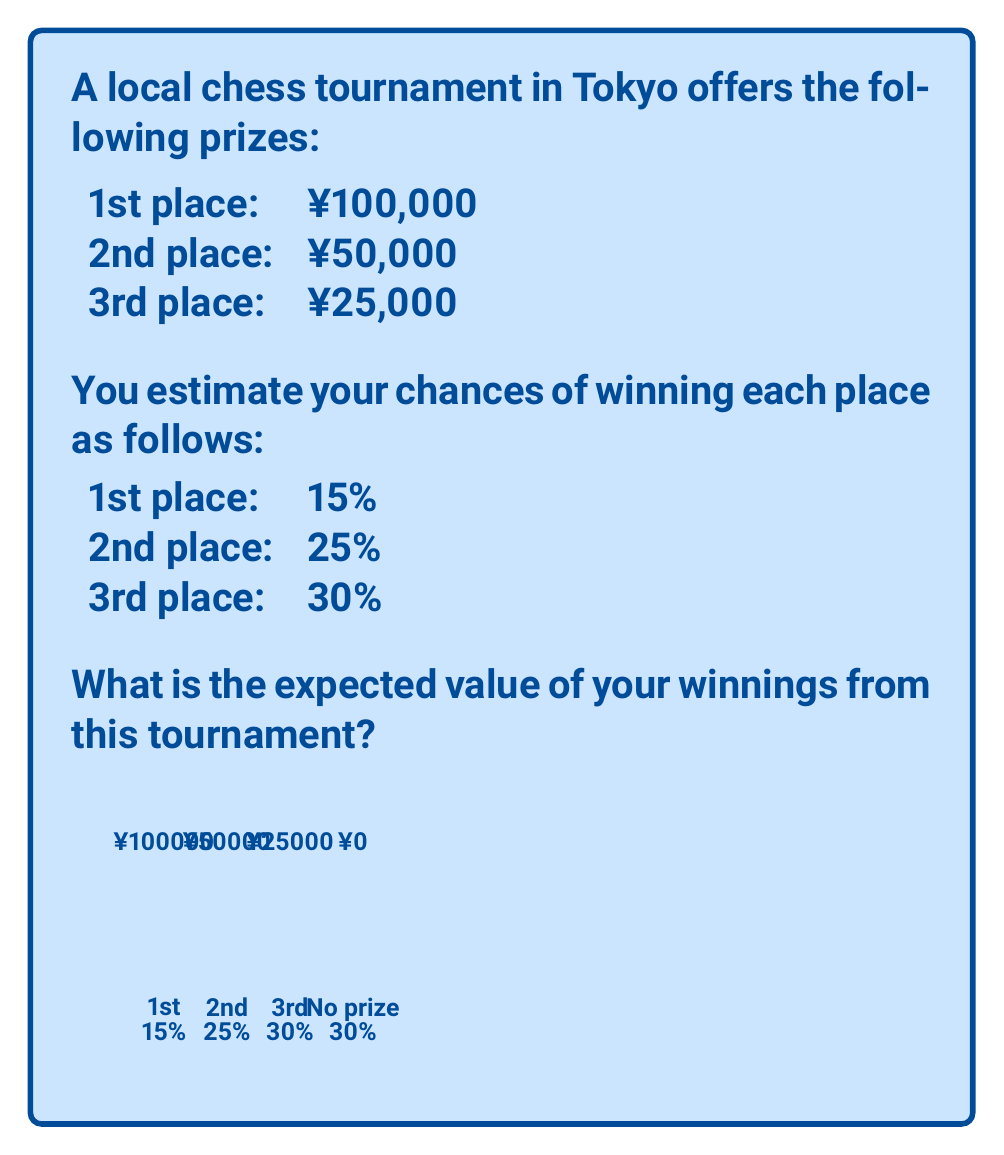Give your solution to this math problem. To calculate the expected value, we need to multiply each possible outcome by its probability and sum these products. Let's break it down step-by-step:

1) For 1st place:
   Probability = 15% = 0.15
   Prize = ¥100,000
   Expected value = $0.15 \times 100000 = 15000$

2) For 2nd place:
   Probability = 25% = 0.25
   Prize = ¥50,000
   Expected value = $0.25 \times 50000 = 12500$

3) For 3rd place:
   Probability = 30% = 0.30
   Prize = ¥25,000
   Expected value = $0.30 \times 25000 = 7500$

4) For no prize:
   Probability = 100% - (15% + 25% + 30%) = 30% = 0.30
   Prize = ¥0
   Expected value = $0.30 \times 0 = 0$

5) The total expected value is the sum of these individual expected values:

   $E = 15000 + 12500 + 7500 + 0 = 35000$

Therefore, the expected value of your winnings from this tournament is ¥35,000.

Note: This calculation assumes that the probabilities are accurate and that there are no other factors affecting the outcome.
Answer: ¥35,000 